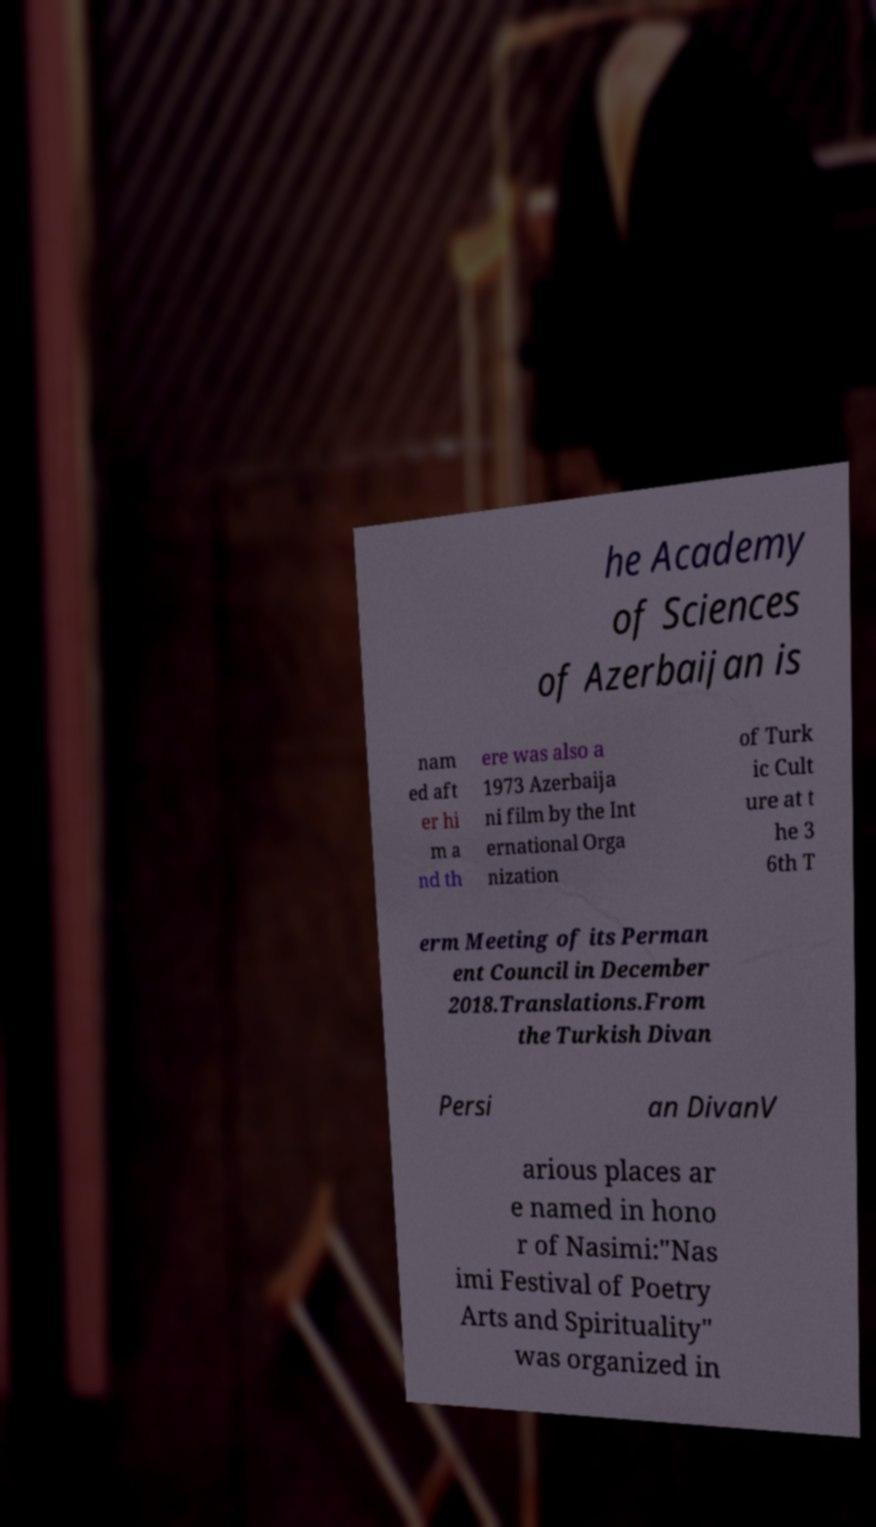Please identify and transcribe the text found in this image. he Academy of Sciences of Azerbaijan is nam ed aft er hi m a nd th ere was also a 1973 Azerbaija ni film by the Int ernational Orga nization of Turk ic Cult ure at t he 3 6th T erm Meeting of its Perman ent Council in December 2018.Translations.From the Turkish Divan Persi an DivanV arious places ar e named in hono r of Nasimi:"Nas imi Festival of Poetry Arts and Spirituality" was organized in 